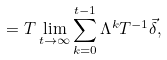<formula> <loc_0><loc_0><loc_500><loc_500>= T \lim _ { t \to \infty } \sum _ { k = 0 } ^ { t - 1 } \Lambda ^ { k } T ^ { - 1 } \vec { \delta } ,</formula> 